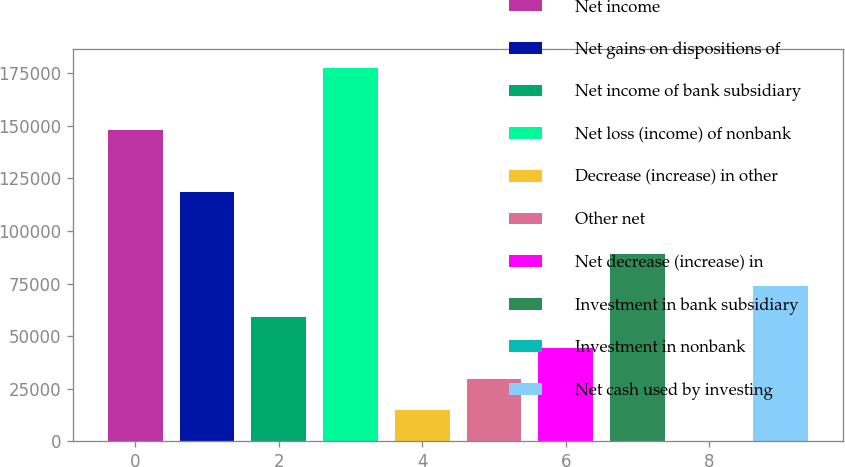<chart> <loc_0><loc_0><loc_500><loc_500><bar_chart><fcel>Net income<fcel>Net gains on dispositions of<fcel>Net income of bank subsidiary<fcel>Net loss (income) of nonbank<fcel>Decrease (increase) in other<fcel>Other net<fcel>Net decrease (increase) in<fcel>Investment in bank subsidiary<fcel>Investment in nonbank<fcel>Net cash used by investing<nl><fcel>148092<fcel>118475<fcel>59239.8<fcel>177709<fcel>14813.7<fcel>29622.4<fcel>44431.1<fcel>88857.2<fcel>5<fcel>74048.5<nl></chart> 